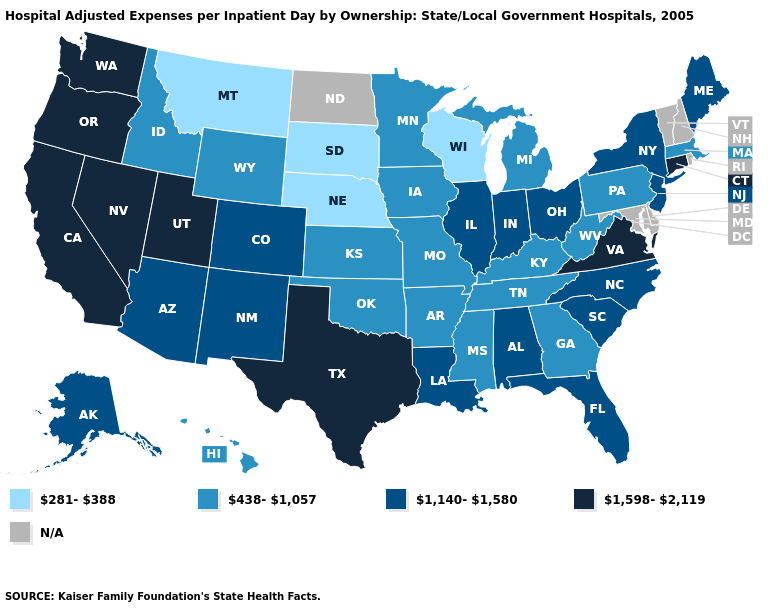Among the states that border Michigan , does Ohio have the lowest value?
Concise answer only. No. What is the value of Indiana?
Concise answer only. 1,140-1,580. Which states have the highest value in the USA?
Short answer required. California, Connecticut, Nevada, Oregon, Texas, Utah, Virginia, Washington. What is the lowest value in the Northeast?
Answer briefly. 438-1,057. What is the highest value in the West ?
Answer briefly. 1,598-2,119. Is the legend a continuous bar?
Quick response, please. No. Is the legend a continuous bar?
Write a very short answer. No. What is the value of Maryland?
Write a very short answer. N/A. Name the states that have a value in the range N/A?
Write a very short answer. Delaware, Maryland, New Hampshire, North Dakota, Rhode Island, Vermont. Does Massachusetts have the highest value in the Northeast?
Answer briefly. No. What is the value of Kansas?
Quick response, please. 438-1,057. Name the states that have a value in the range 1,140-1,580?
Give a very brief answer. Alabama, Alaska, Arizona, Colorado, Florida, Illinois, Indiana, Louisiana, Maine, New Jersey, New Mexico, New York, North Carolina, Ohio, South Carolina. 